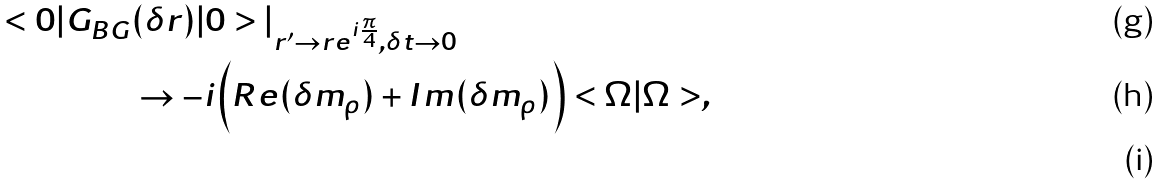<formula> <loc_0><loc_0><loc_500><loc_500>< 0 | G _ { B G } & ( \delta r ) | 0 > | _ { r ^ { \prime } \to r e ^ { i \frac { \pi } { 4 } } , \delta t \to 0 } \\ & \to - i \Big { ( } R e ( \delta m _ { \rho } ) + I m ( \delta m _ { \rho } ) \Big { ) } < \Omega | \Omega > , \\</formula> 